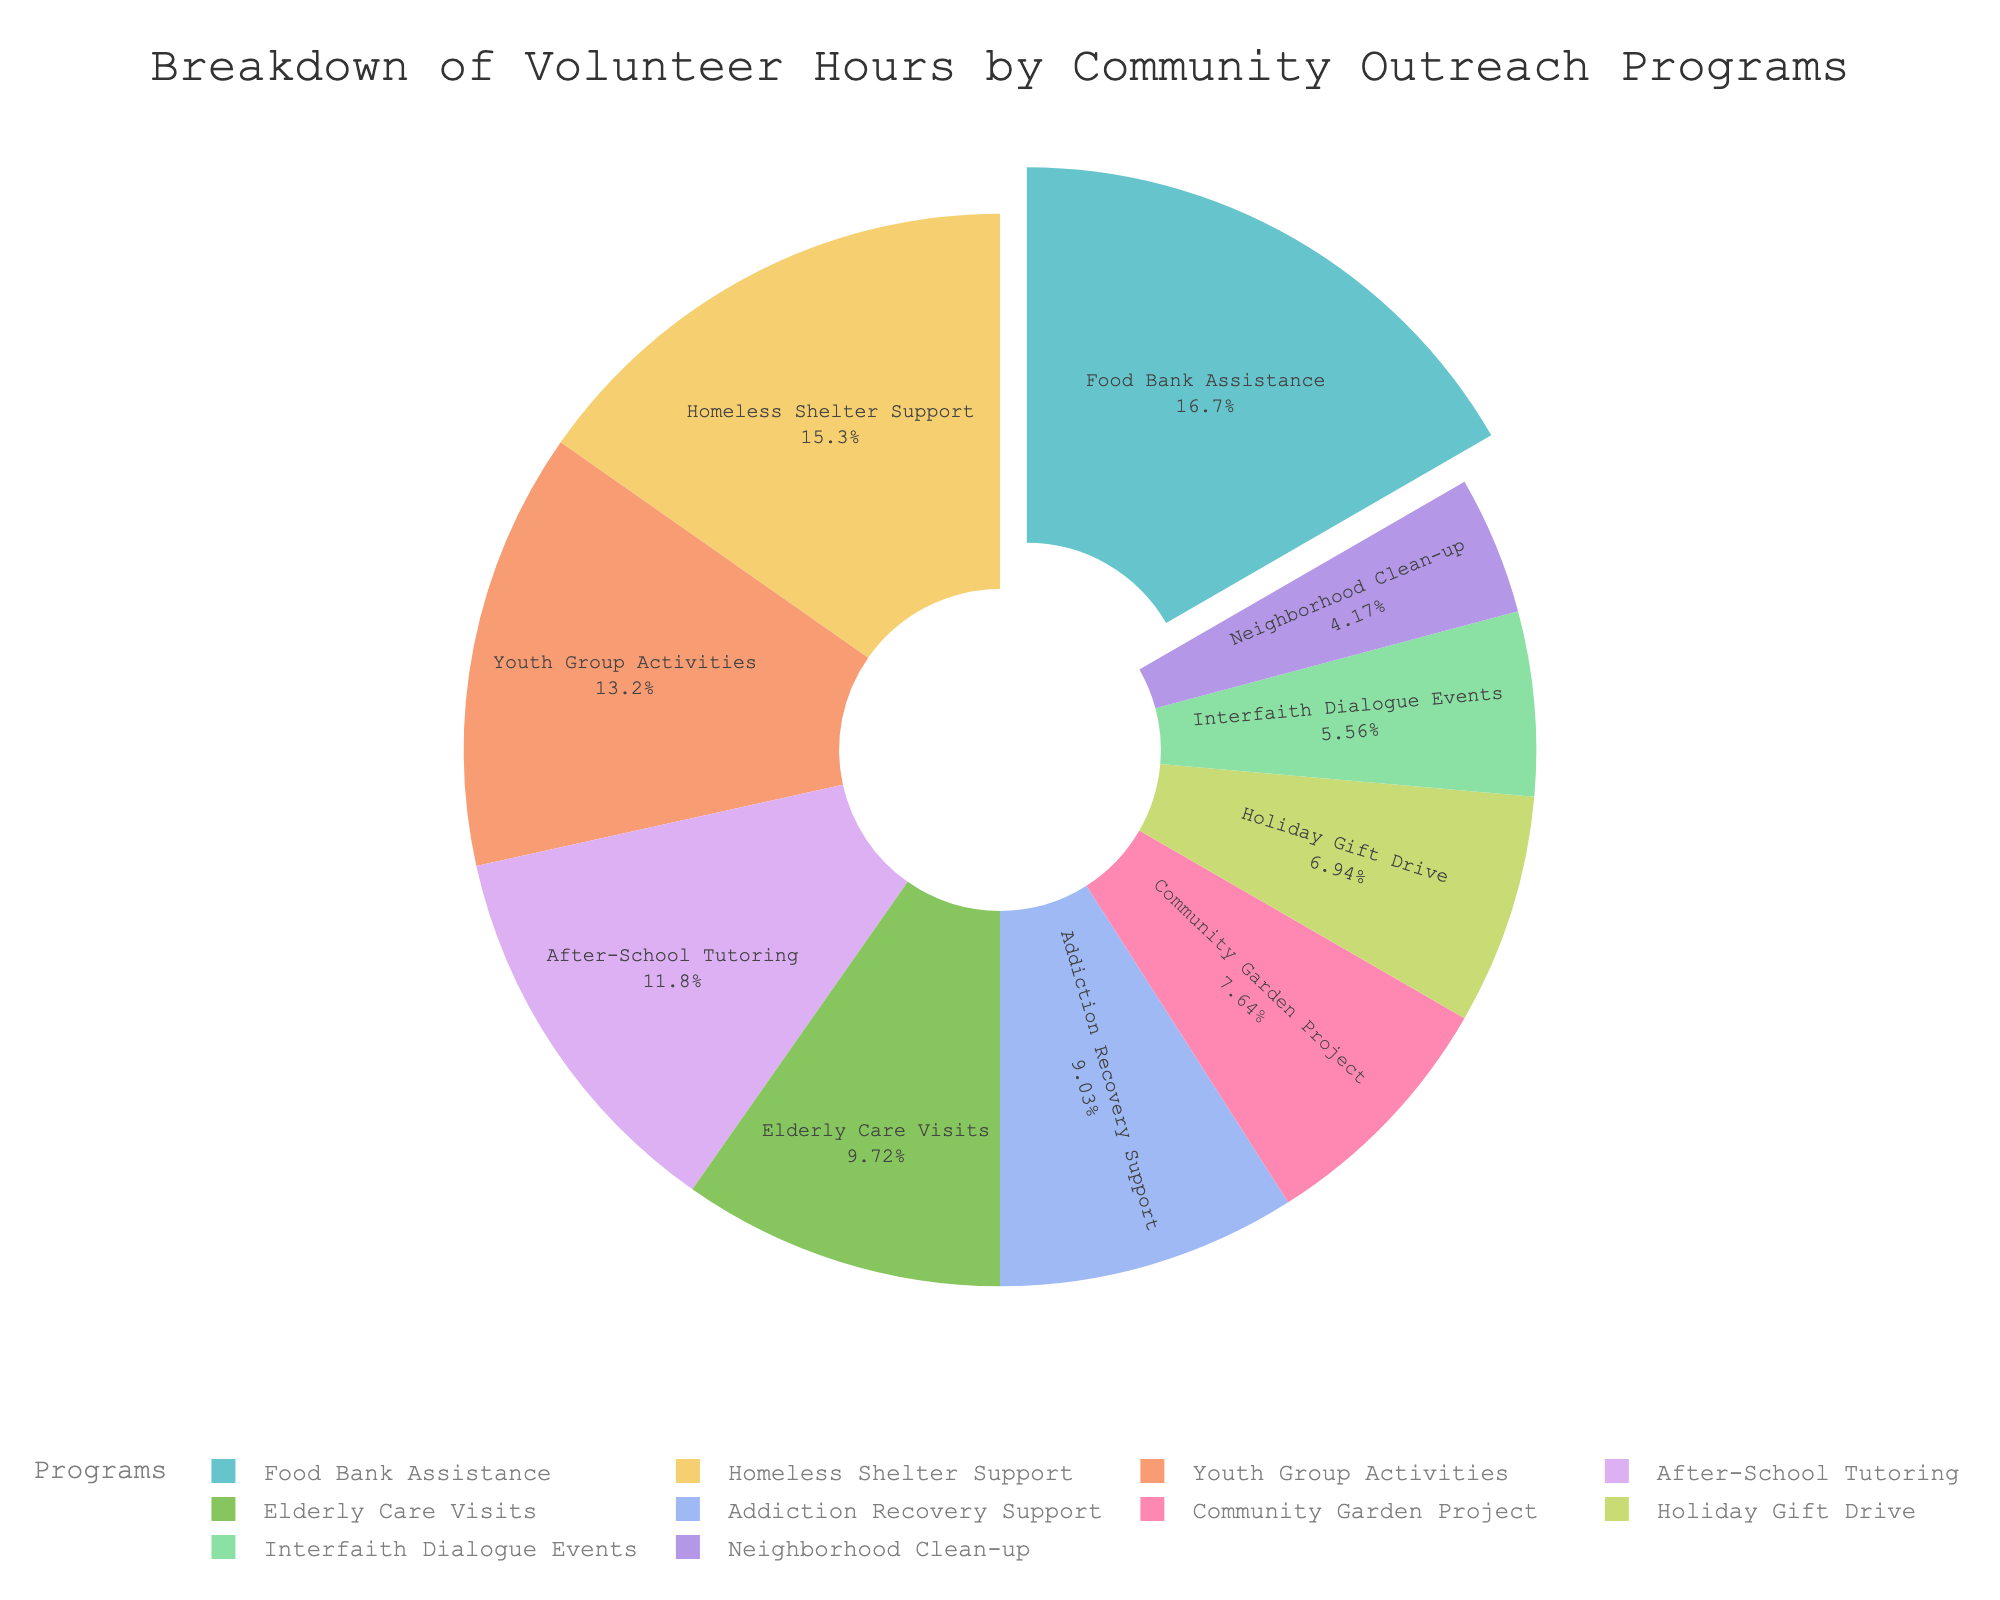Which program has the highest number of volunteer hours? By inspecting the pie chart, identify the segment with the largest area or percentage labeled, corresponding to the "Food Bank Assistance" program.
Answer: Food Bank Assistance What percentage of the total volunteer hours does the "Youth Group Activities" program represent? Referring to the pie chart, locate the segment labeled "Youth Group Activities" and read the percentage indicated within that segment.
Answer: Approximately 14.6% How many more hours were contributed to "Homeless Shelter Support" compared to "Community Garden Project"? Look at the pie chart and note the hours for both "Homeless Shelter Support" (110 hours) and "Community Garden Project" (55 hours). Subtract the hours for the Community Garden Project from the hours for Homeless Shelter Support (110 - 55).
Answer: 55 Which program has the smallest share of volunteer hours? Inspect the pie chart to find the smallest segment, which corresponds to the "Neighborhood Clean-up" program.
Answer: Neighborhood Clean-up What is the combined percentage for "Food Bank Assistance" and "After-School Tutoring"? Identify the percentages for both "Food Bank Assistance" and "After-School Tutoring" in the pie chart. Sum these percentages; if "Food Bank Assistance" is approximately 20.7% and "After-School Tutoring" is approximately 14.6%, then the combined percentage is (20.7% + 14.6%).
Answer: Approximately 35.3% By how many hours does "After-School Tutoring" exceed "Holiday Gift Drive"? Find the hours indicated for both "After-School Tutoring" (85 hours) and "Holiday Gift Drive" (50 hours) in the pie chart. Subtract the hours for "Holiday Gift Drive" from the hours for "After-School Tutoring" (85 - 50).
Answer: 35 Are there any programs with an equal number of volunteer hours? Observe the pie chart for segments labeled with equal hours. Cross-reference their values; in this case, no segments have the same hours according to the data provided.
Answer: No Which programs together contribute an equal share to "Food Bank Assistance"? Identify the percentage contribution of "Food Bank Assistance" from the pie chart (approximately 20.7%). Combine percentages from other programs to match this value, e.g., "Addiction Recovery Support" (approximately 11.2%) and "Youth Group Activities" (approximately 14.6%) sum to more than 20.7%. So, find combinations summing to approximately 20.7%.
Answer: None directly match, multiple smaller programs needed What percentage of the volunteer hours is dedicated to religious events like "Interfaith Dialogue Events" and "Addiction Recovery Support" combined? Find the percentages for "Interfaith Dialogue Events" (around 8%) and "Addiction Recovery Support" (around 10.6%). Sum these percentages (8% + 10.6%).
Answer: Approximately 18.6% 